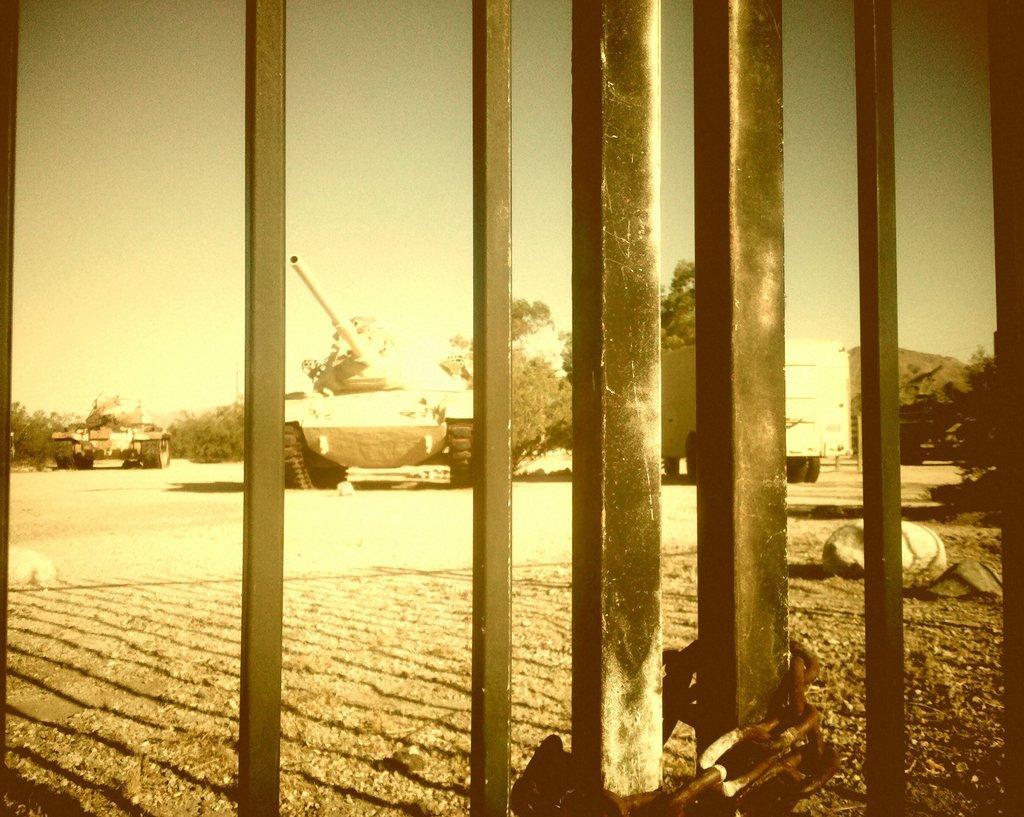How would you summarize this image in a sentence or two? In this image I can see an iron gate which is tied with a chain, also there is a shadow of it. There are two different war tanks, trees, there is a truck and in the background there is sky. 